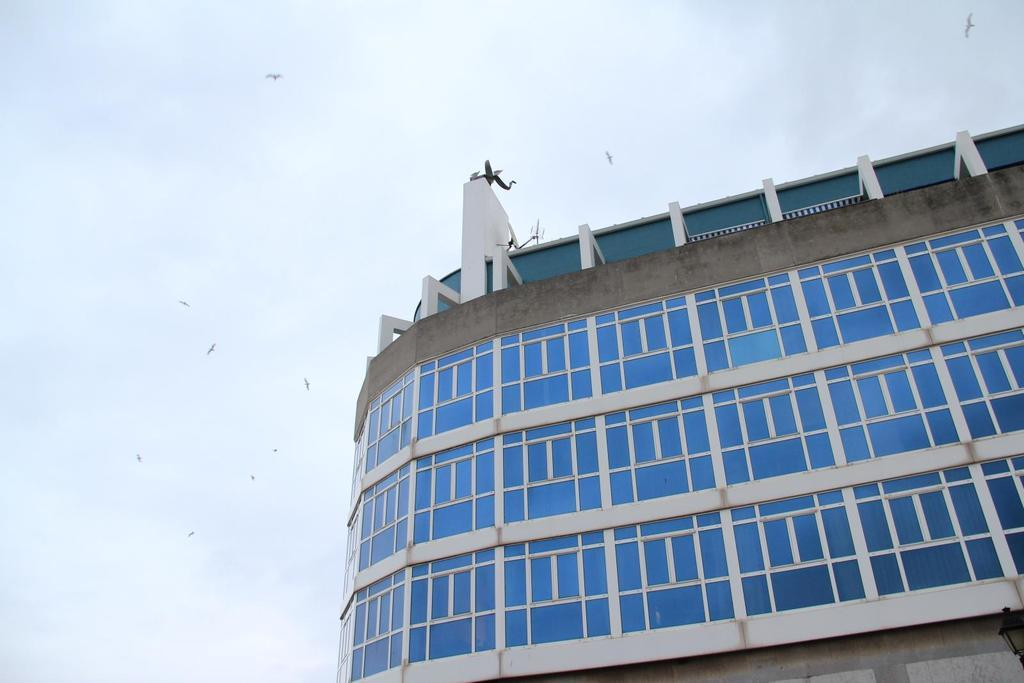What structure is located towards the right side of the image? There is a building towards the right side of the image. What is visible on the right side and at the top of the image? The sky is visible on the right side and at the top of the image. What can be seen in the sky in the image? There are birds in the sky. What is the level of disgust expressed by the building in the image? The building is an inanimate object and cannot express disgust. 